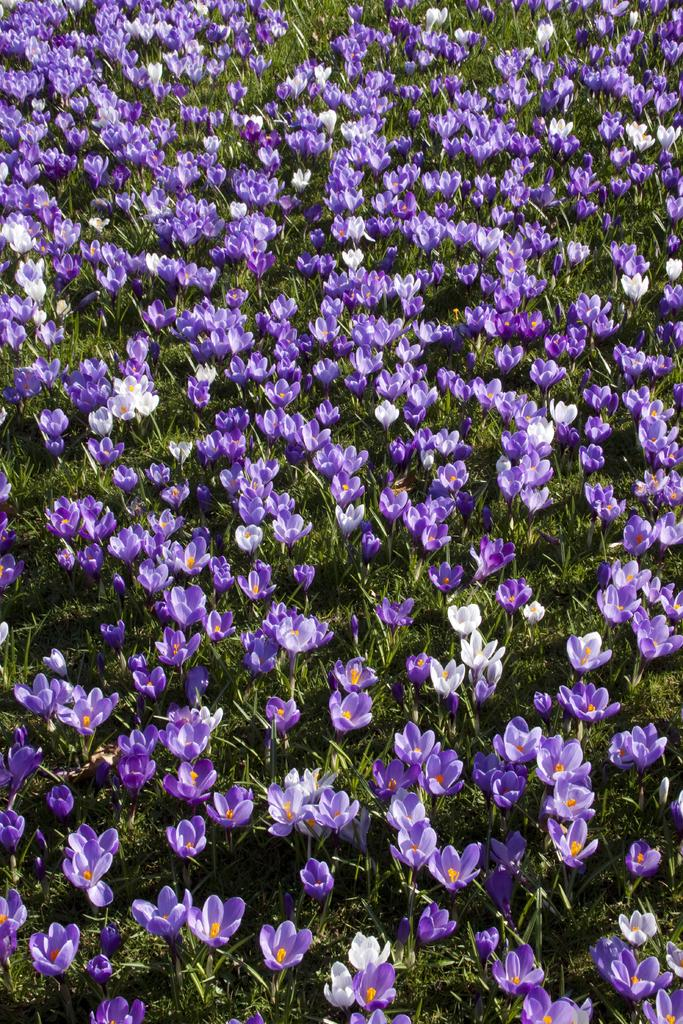What types of flowers can be seen in the image? There are purple flowers and white flowers in the image. What else is present in the image besides flowers? There is grass in the image. What nation is represented by the ants in the image? There are no ants present in the image, so it is not possible to determine which nation they might represent. 